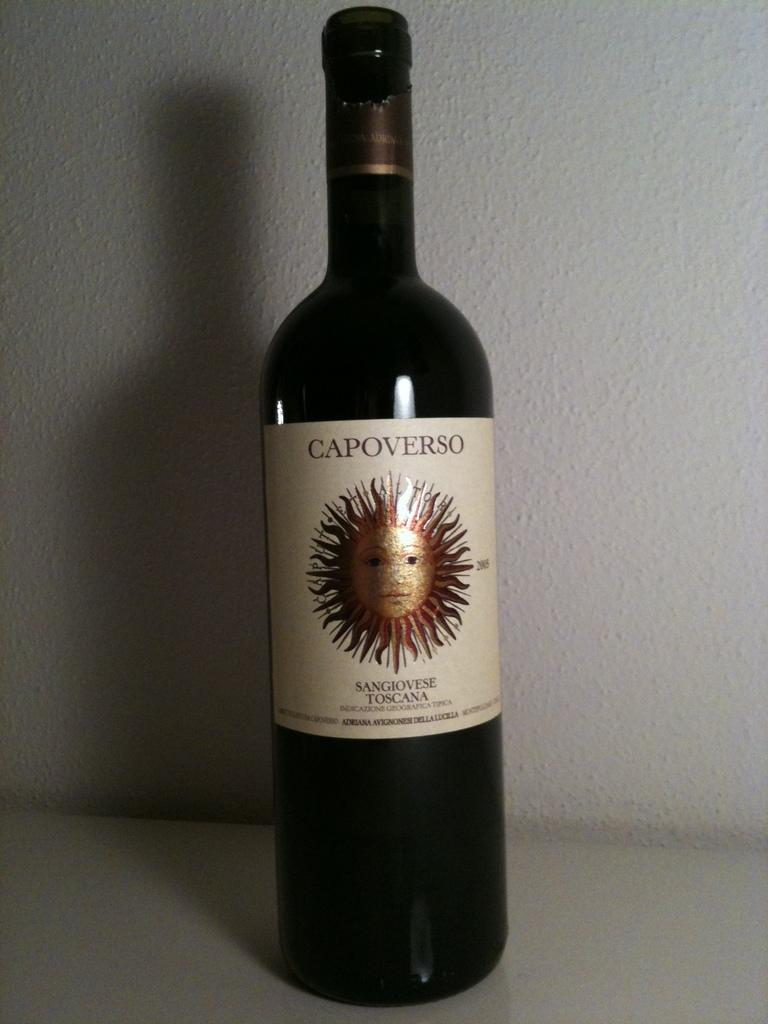<image>
Summarize the visual content of the image. A bottle of wine called CAPOVERSO Sangiovese Toscana is sitting on an all white table. 